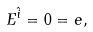Convert formula to latex. <formula><loc_0><loc_0><loc_500><loc_500>E ^ { \hat { i } } = 0 = e ,</formula> 